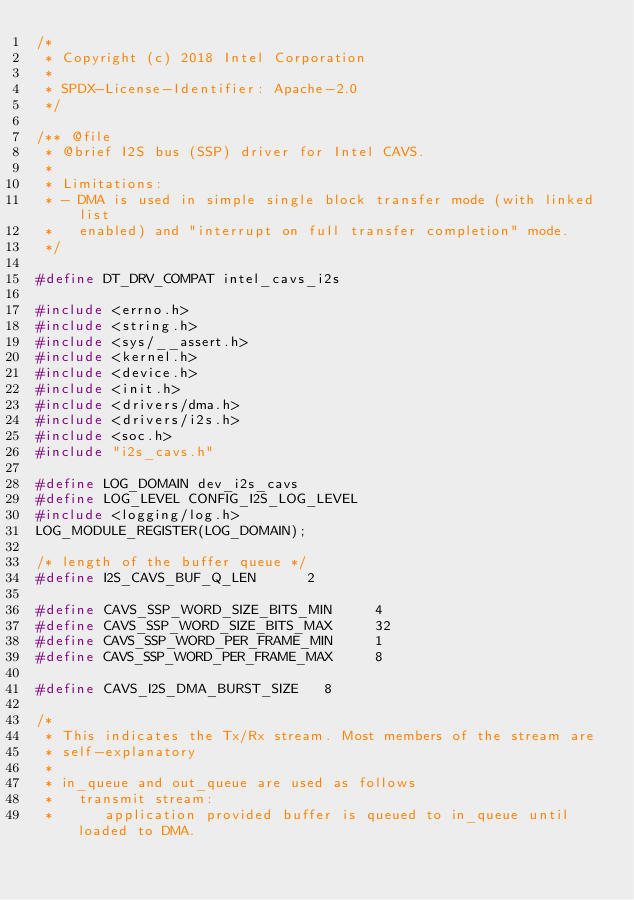<code> <loc_0><loc_0><loc_500><loc_500><_C_>/*
 * Copyright (c) 2018 Intel Corporation
 *
 * SPDX-License-Identifier: Apache-2.0
 */

/** @file
 * @brief I2S bus (SSP) driver for Intel CAVS.
 *
 * Limitations:
 * - DMA is used in simple single block transfer mode (with linked list
 *   enabled) and "interrupt on full transfer completion" mode.
 */

#define DT_DRV_COMPAT intel_cavs_i2s

#include <errno.h>
#include <string.h>
#include <sys/__assert.h>
#include <kernel.h>
#include <device.h>
#include <init.h>
#include <drivers/dma.h>
#include <drivers/i2s.h>
#include <soc.h>
#include "i2s_cavs.h"

#define LOG_DOMAIN dev_i2s_cavs
#define LOG_LEVEL CONFIG_I2S_LOG_LEVEL
#include <logging/log.h>
LOG_MODULE_REGISTER(LOG_DOMAIN);

/* length of the buffer queue */
#define I2S_CAVS_BUF_Q_LEN			2

#define CAVS_SSP_WORD_SIZE_BITS_MIN     4
#define CAVS_SSP_WORD_SIZE_BITS_MAX     32
#define CAVS_SSP_WORD_PER_FRAME_MIN     1
#define CAVS_SSP_WORD_PER_FRAME_MAX     8

#define CAVS_I2S_DMA_BURST_SIZE		8

/*
 * This indicates the Tx/Rx stream. Most members of the stream are
 * self-explanatory
 *
 * in_queue and out_queue are used as follows
 *   transmit stream:
 *      application provided buffer is queued to in_queue until loaded to DMA.</code> 